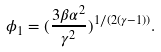Convert formula to latex. <formula><loc_0><loc_0><loc_500><loc_500>\phi _ { 1 } = ( \frac { 3 \beta \alpha ^ { 2 } } { \gamma ^ { 2 } } ) ^ { 1 / ( 2 ( \gamma - 1 ) ) } .</formula> 